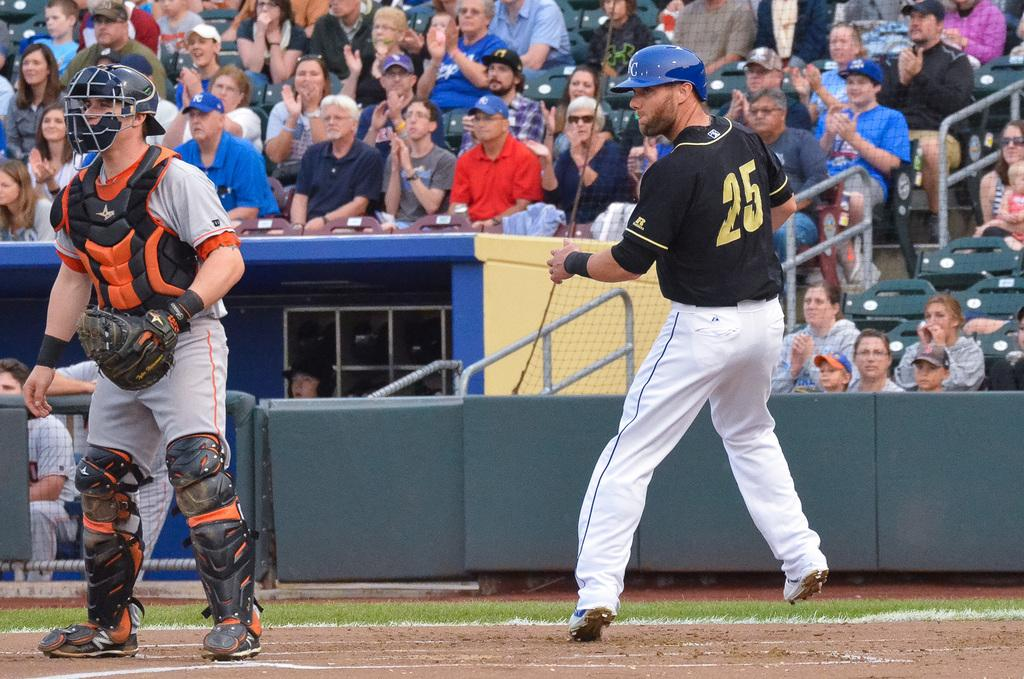<image>
Create a compact narrative representing the image presented. A baseball player is standing by home plate and wearing a black uniform that says 25 in gold letters. 